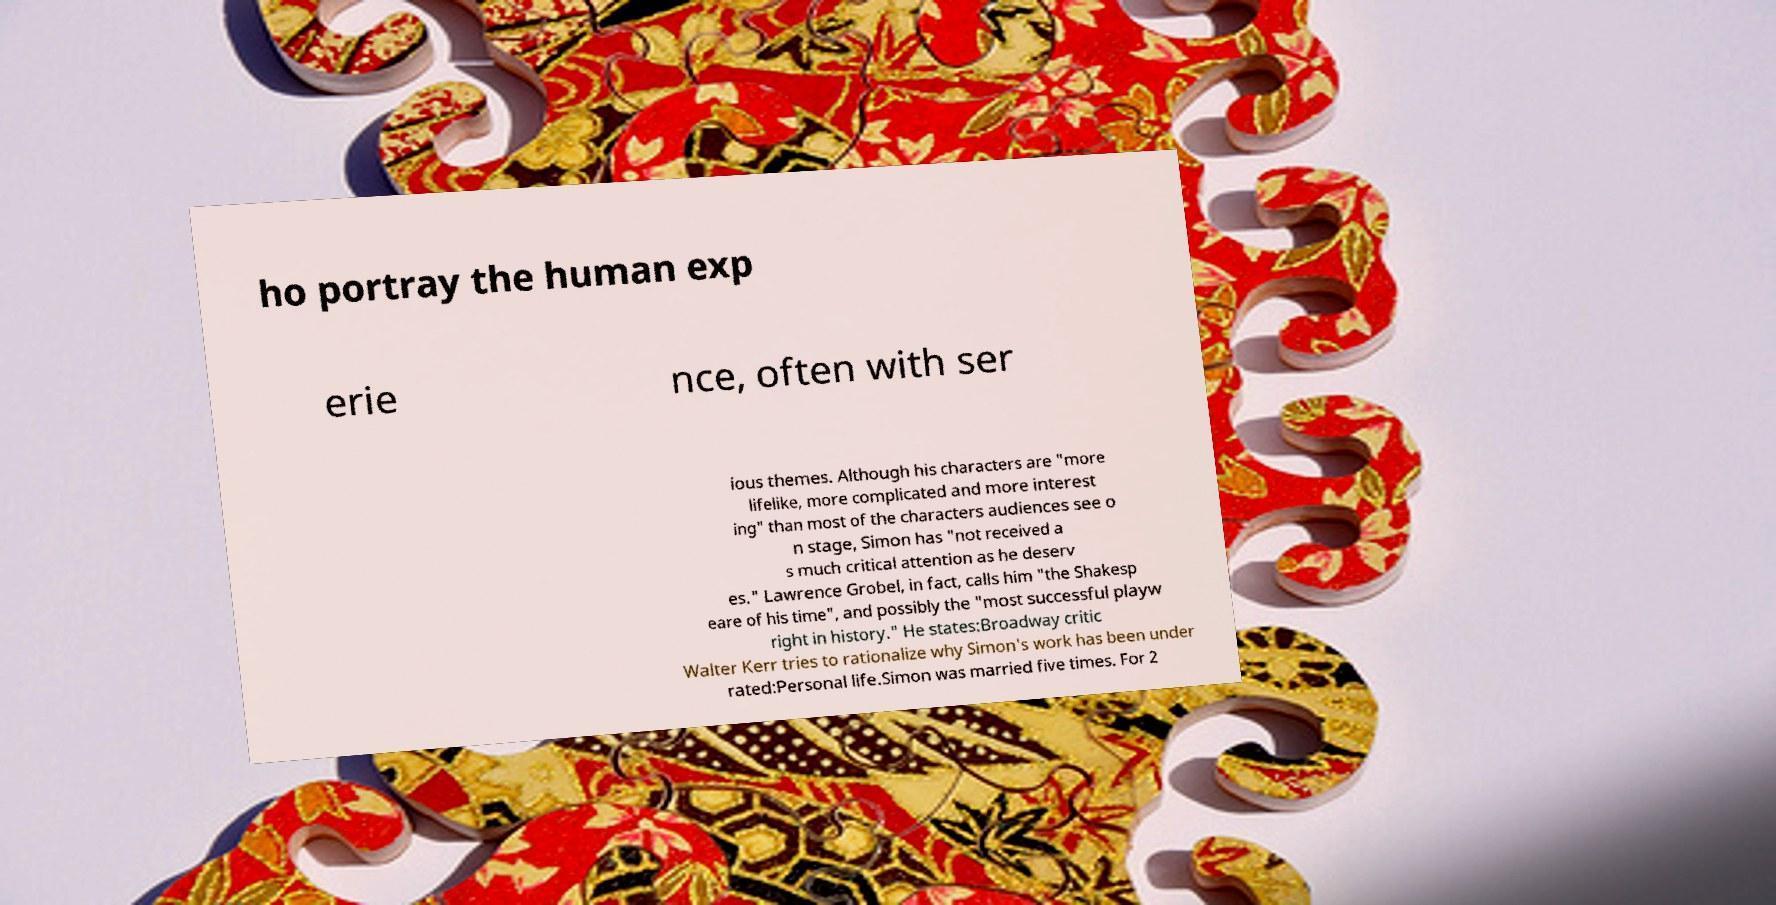Could you extract and type out the text from this image? ho portray the human exp erie nce, often with ser ious themes. Although his characters are "more lifelike, more complicated and more interest ing" than most of the characters audiences see o n stage, Simon has "not received a s much critical attention as he deserv es." Lawrence Grobel, in fact, calls him "the Shakesp eare of his time", and possibly the "most successful playw right in history." He states:Broadway critic Walter Kerr tries to rationalize why Simon's work has been under rated:Personal life.Simon was married five times. For 2 